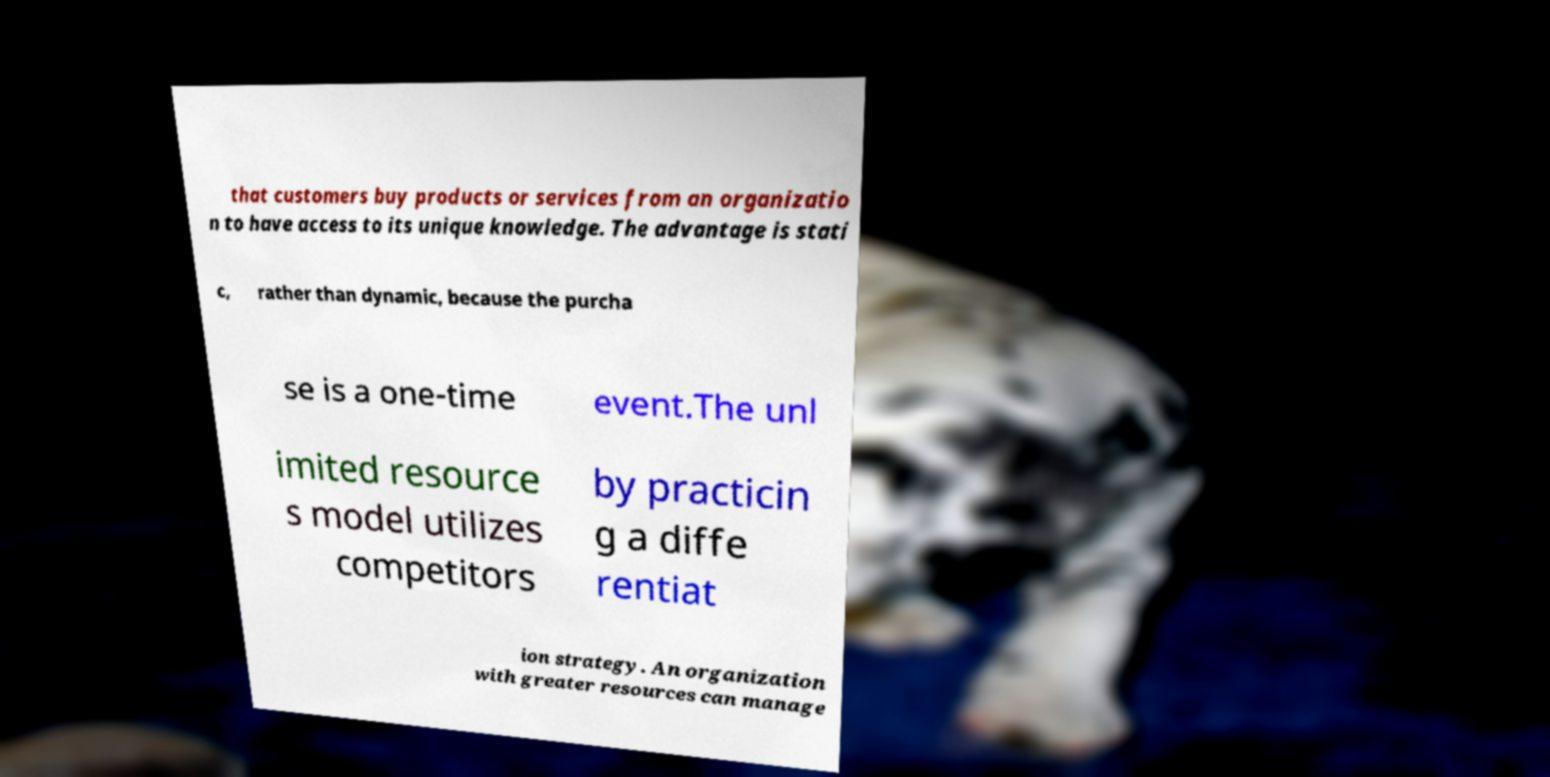What messages or text are displayed in this image? I need them in a readable, typed format. that customers buy products or services from an organizatio n to have access to its unique knowledge. The advantage is stati c, rather than dynamic, because the purcha se is a one-time event.The unl imited resource s model utilizes competitors by practicin g a diffe rentiat ion strategy. An organization with greater resources can manage 